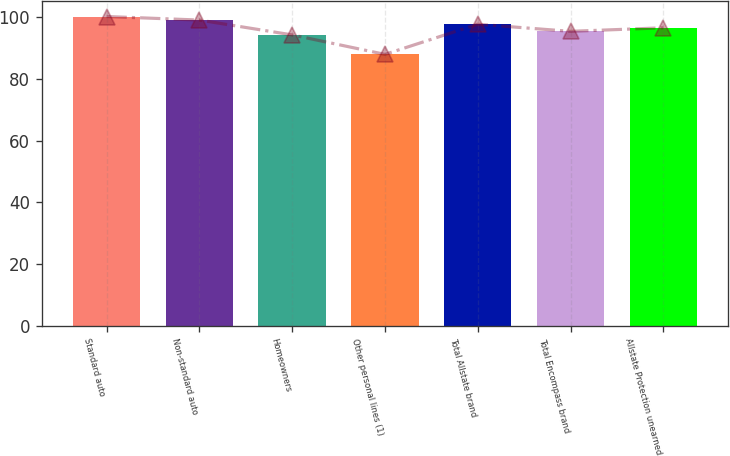<chart> <loc_0><loc_0><loc_500><loc_500><bar_chart><fcel>Standard auto<fcel>Non-standard auto<fcel>Homeowners<fcel>Other personal lines (1)<fcel>Total Allstate brand<fcel>Total Encompass brand<fcel>Allstate Protection unearned<nl><fcel>100.15<fcel>99<fcel>94.2<fcel>87.9<fcel>97.65<fcel>95.35<fcel>96.5<nl></chart> 